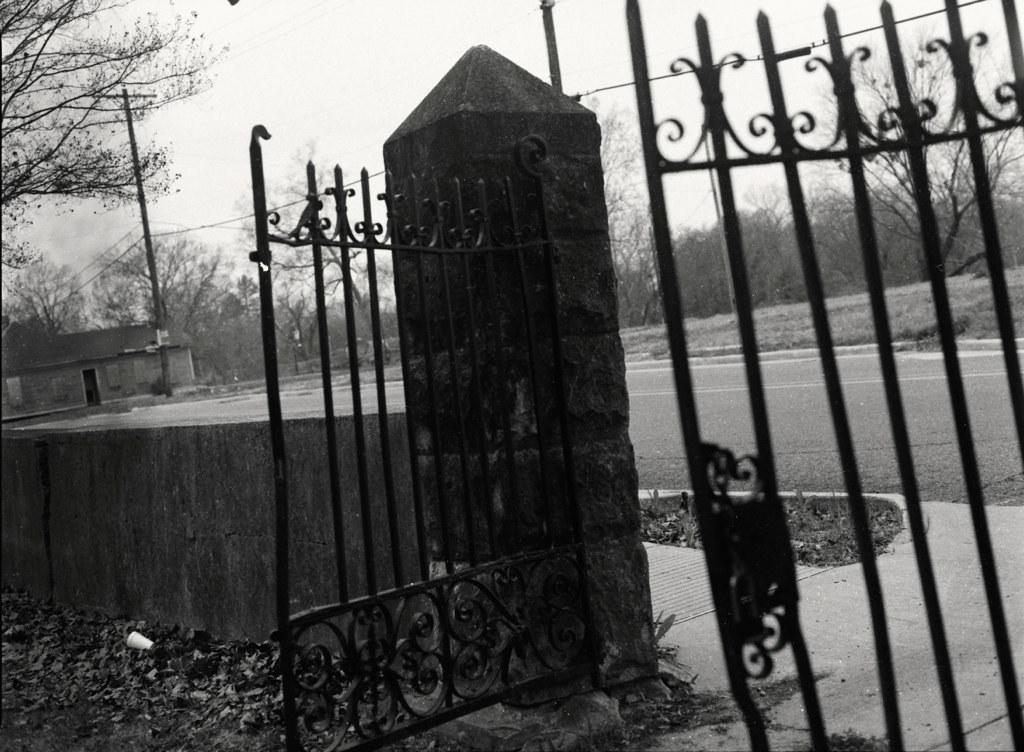Could you give a brief overview of what you see in this image? In this picture we can see grill gate grill and small boundary wall. In the background we can see small shed house, electric pole and some trees. 